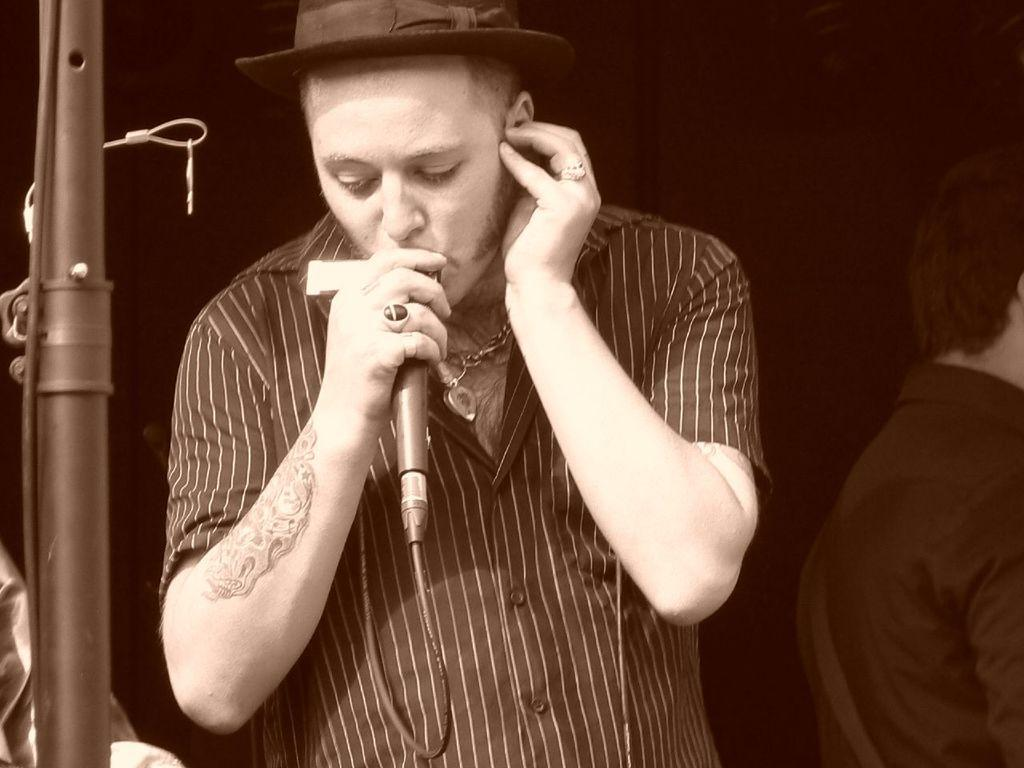Who is the main subject in the image? There is a man in the image. What is the man wearing on his head? The man is wearing a hat. What is the man holding in his hand? The man is holding a microphone. Can you describe any visible body art on the man? The man has a tattoo on the right side of his hand. What type of chicken can be seen in the image? There is no chicken present in the image. How does the wind affect the man's hat in the image? There is no wind present in the image, and therefore it does not affect the man's hat. 